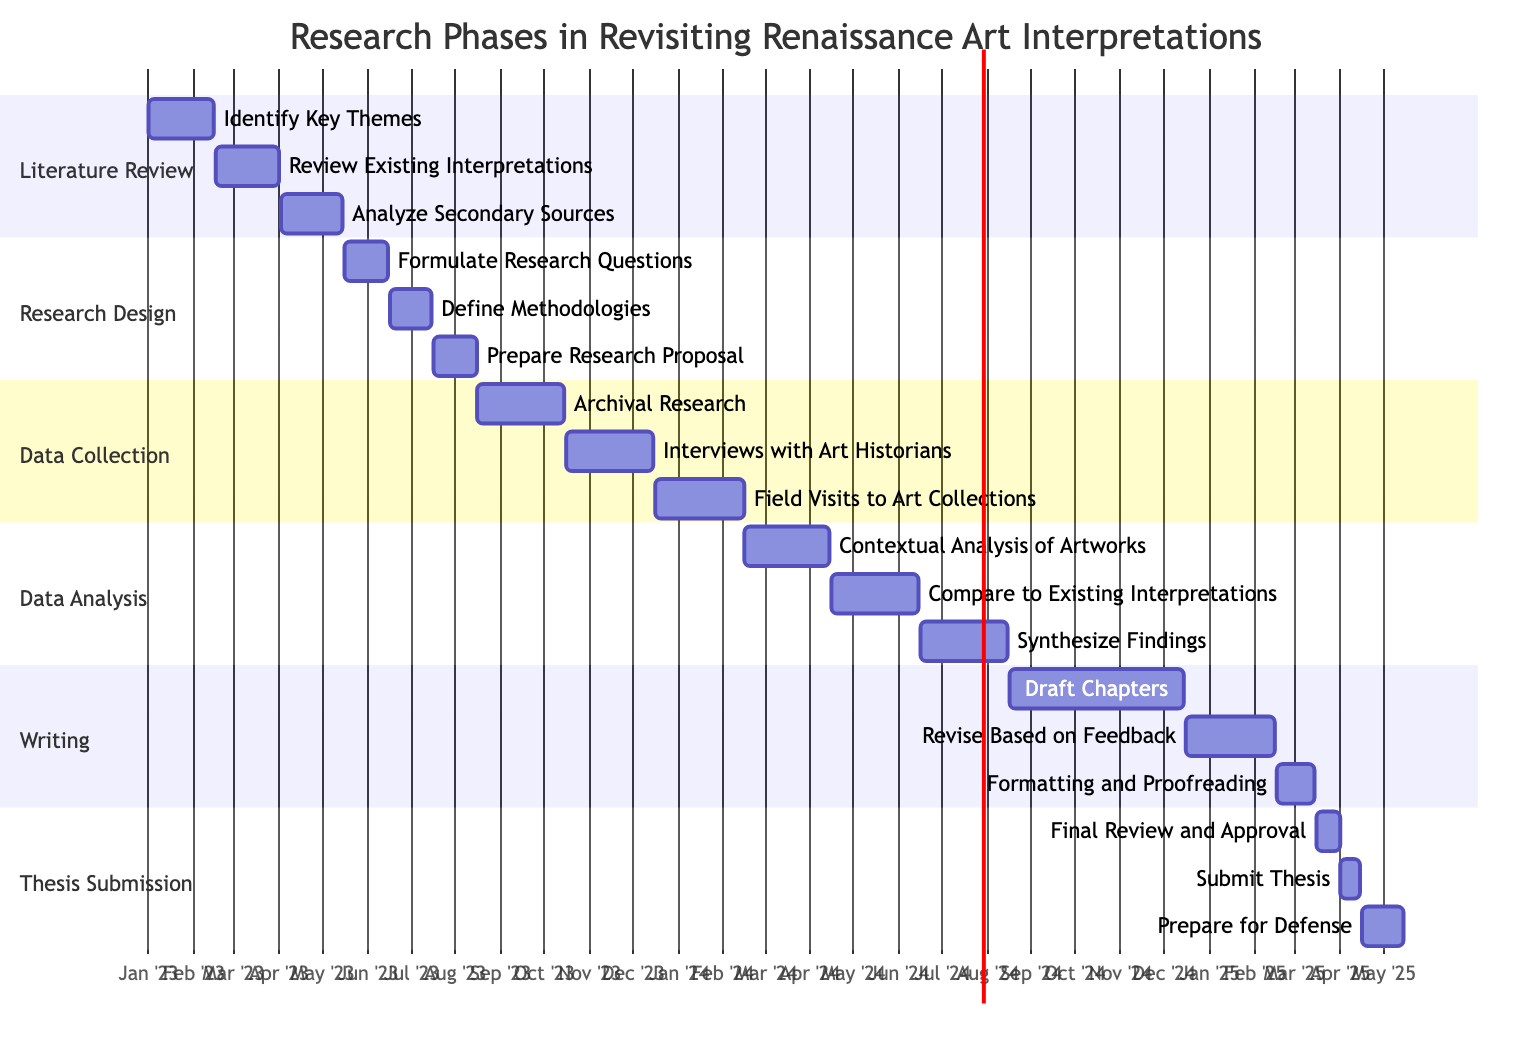What is the duration of the Literature Review phase? The Literature Review phase includes three tasks: Identify Key Themes, Review Existing Interpretations, and Analyze Secondary Sources. The overall duration is from January 1, 2023, to May 15, 2023, which can be calculated as the difference between the start of the first task and the end of the last task.
Answer: Four months and fifteen days How many tasks are in the Data Collection phase? The Data Collection phase has three tasks: Archival Research, Interviews with Art Historians, and Field Visits to Art Collections. The total is counted directly from the listed tasks.
Answer: Three tasks Which task follows "Define Methodologies" in the Research Design phase? The task that follows "Define Methodologies" is "Prepare Research Proposal." The sequential order of tasks within the section allows for direct identification.
Answer: Prepare Research Proposal When does the Draft Chapters task begin? "Draft Chapters" begins on August 16, 2024. The specific start date is provided in the task's associated data.
Answer: August 16, 2024 What is the end date for the Synthesize Findings task? The end date for “Synthesize Findings” is August 15, 2024, as listed under the tasks for the Data Analysis phase.
Answer: August 15, 2024 What are the tasks occurring simultaneously in the thesis submission phase? In the Thesis Submission phase, the tasks "Final Review and Approval" and "Submit Thesis" overlap in terms of presentation layout, but they have sequential end and start dates. "Final Review and Approval" ends on April 1, 2025, and "Submit Thesis" starts on April 2, 2025, thus they do not occur simultaneously.
Answer: No simultaneous tasks What task has the same ending date as "Formatting and Proofreading"? The task "Submit Thesis" has the same ending date as "Formatting and Proofreading." Checking both tasks for completion dates identifies this relationship.
Answer: Formatting and Proofreading What phase spans from May 16, 2023, to August 15, 2023? The phase that spans from May 16, 2023, to August 15, 2023, is the Research Design phase. This time frame is established by examining the task start and end dates in the diagram.
Answer: Research Design 